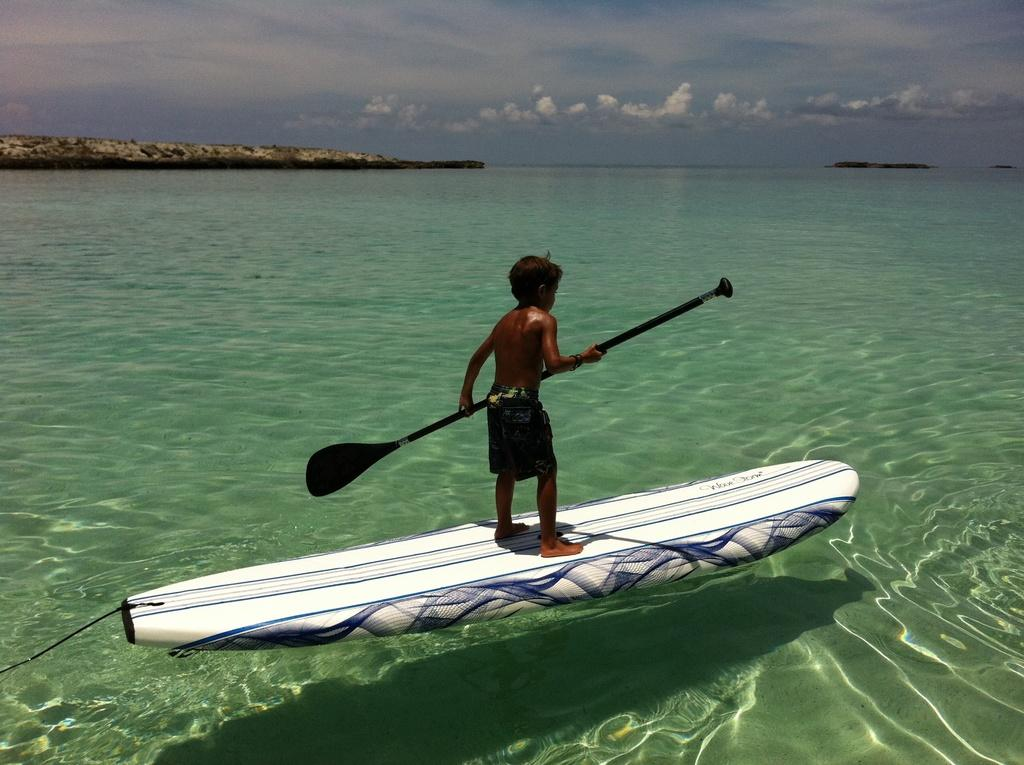Who is the main subject in the image? There is a boy in the image. What is the boy doing in the image? The boy is standing on a paddle board and holding a paddle. What type of environment is depicted in the image? The image appears to depict a sea or body of water. What other objects or features can be seen in the image? There are rocks visible in the image, and the sky is visible with clouds. What type of horn can be seen on the boy's shoes in the image? There are no shoes or horns present in the image. 